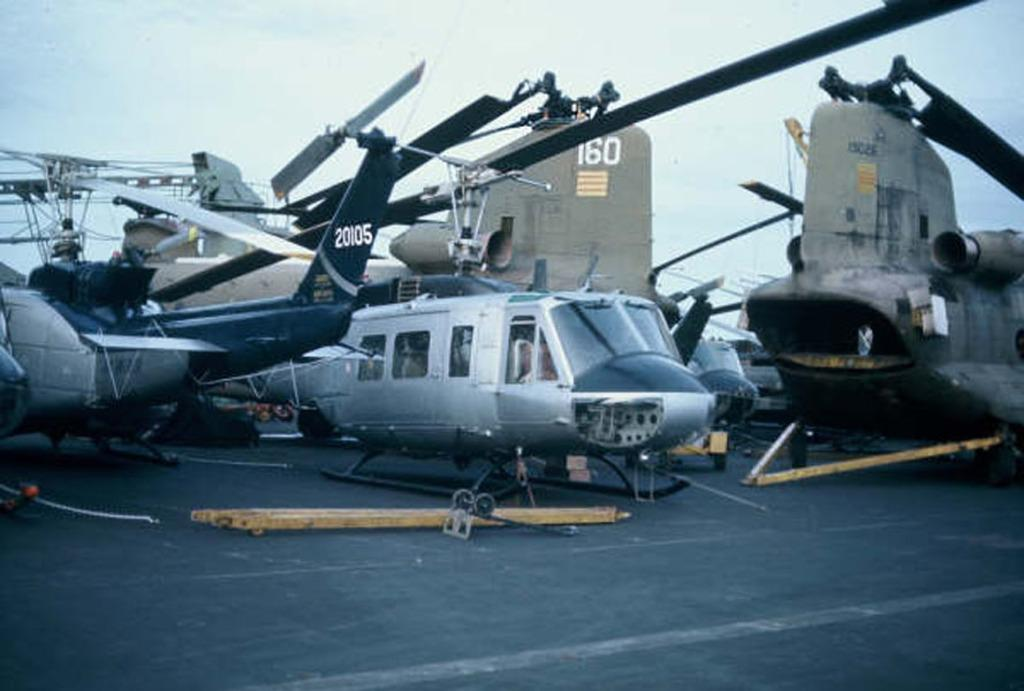<image>
Relay a brief, clear account of the picture shown. Plane number 20105 is parked outside next to several other planes. 